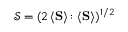Convert formula to latex. <formula><loc_0><loc_0><loc_500><loc_500>\mathcal { S } = ( 2 \, \langle { S } \rangle \colon \langle { S } \rangle ) ^ { 1 / 2 }</formula> 